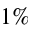<formula> <loc_0><loc_0><loc_500><loc_500>1 \%</formula> 